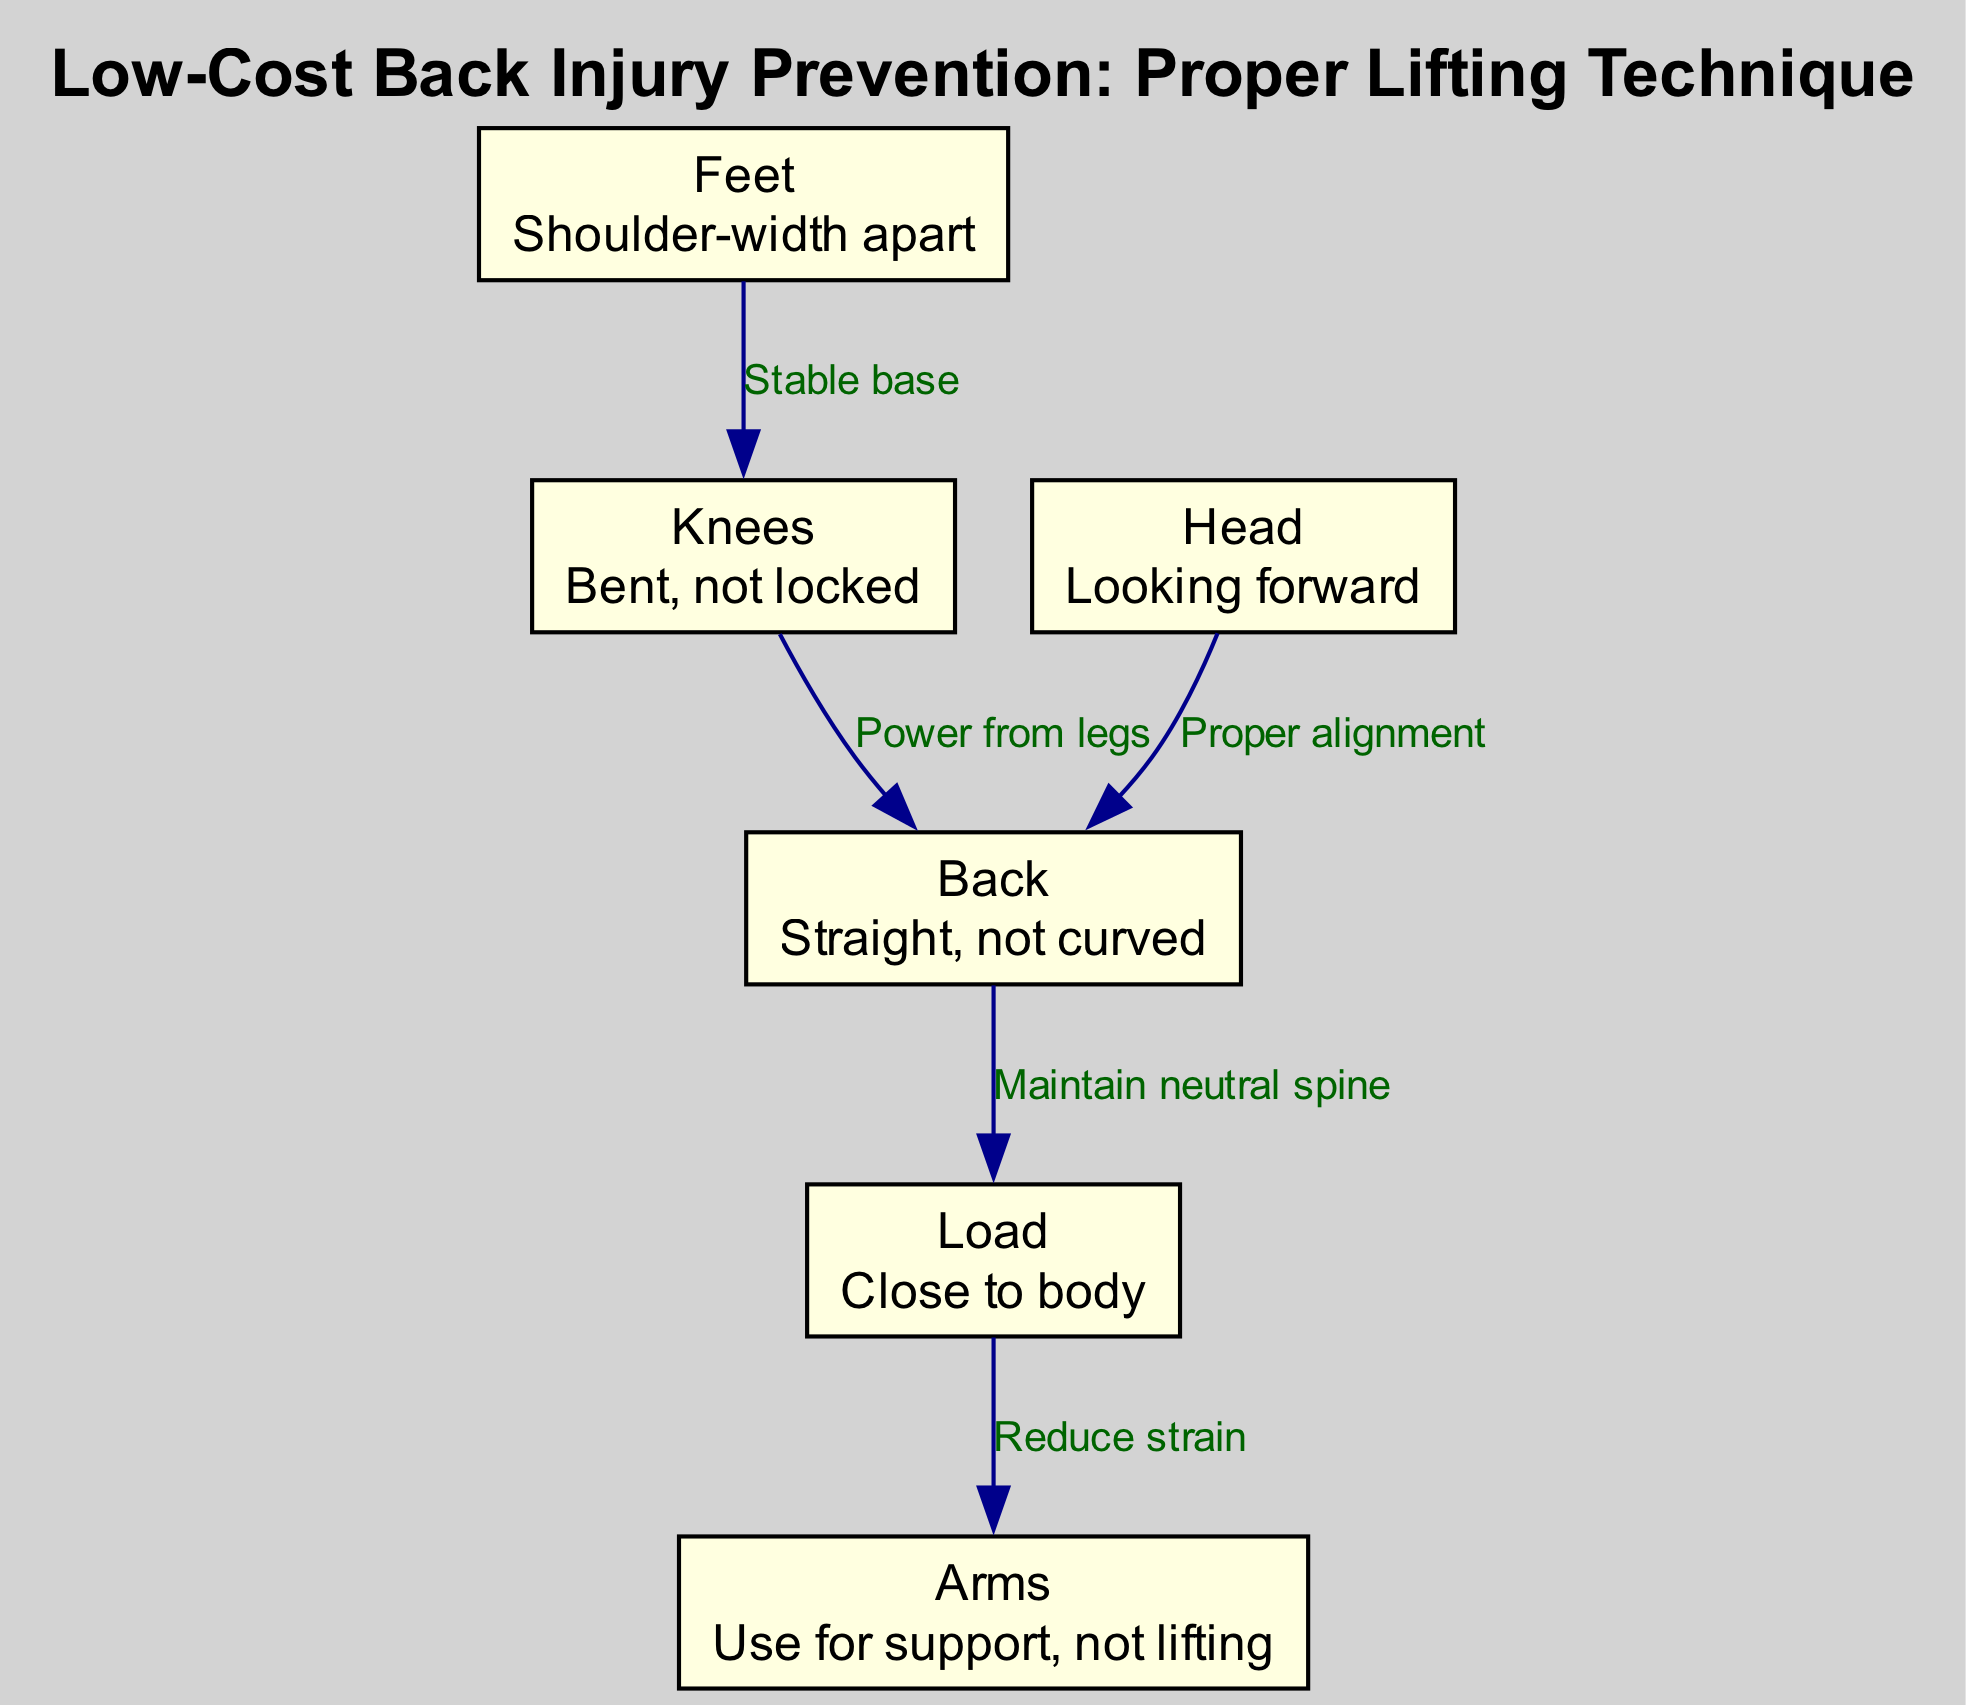What is the distance indicated for the feet position? The diagram specifies that the feet should be placed shoulder-width apart. This means the appropriate measure is the distance between the outer edges of the feet when positioned for lifting.
Answer: Shoulder-width apart How many nodes are in the diagram? The diagram consists of six distinct nodes that represent different aspects of proper lifting techniques, including feet, knees, back, load, arms, and head.
Answer: Six What should the knees be like during lifting? The diagram states that the knees should be bent and not locked. This ensures flexibility and a stable base while lifting heavy objects.
Answer: Bent, not locked What do the arms provide during lifting? According to the diagram, the arms are used for support instead of lifting, which helps to reduce the strain on the back and fosters better lifting techniques.
Answer: Support, not lifting What is the relationship between the back and the load? The diagram indicates that maintaining a straight back relates to keeping the load close to the body. This principle helps to protect the spine and distribute weight appropriately while lifting.
Answer: Maintain neutral spine What is the direction indicated for the head? The diagram instructs that the head should be looking forward while lifting. This maintains proper alignment and helps balance the body during the lift.
Answer: Looking forward How does power relate to the knees and back? The diagram shows a connection from knees to back, highlighting that power should come from the legs when lifting, which emphasizes using the strength of the lower body rather than straining the back.
Answer: Power from legs What type of base should the feet create? The diagram notes that feet positioned shoulder-width apart create a stable base, essential for maintaining balance and support during lifting tasks.
Answer: Stable base 